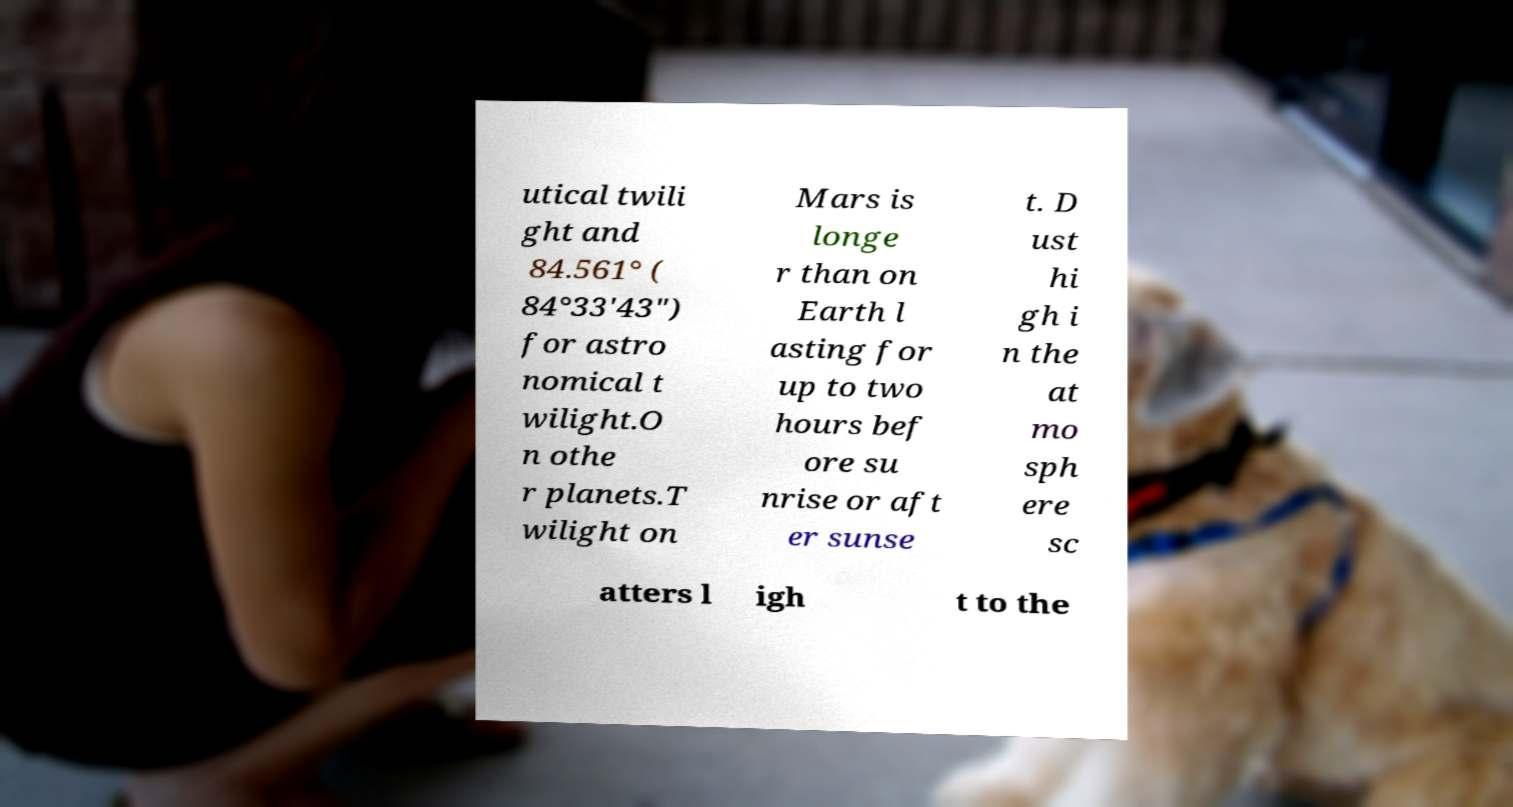Could you extract and type out the text from this image? utical twili ght and 84.561° ( 84°33′43″) for astro nomical t wilight.O n othe r planets.T wilight on Mars is longe r than on Earth l asting for up to two hours bef ore su nrise or aft er sunse t. D ust hi gh i n the at mo sph ere sc atters l igh t to the 